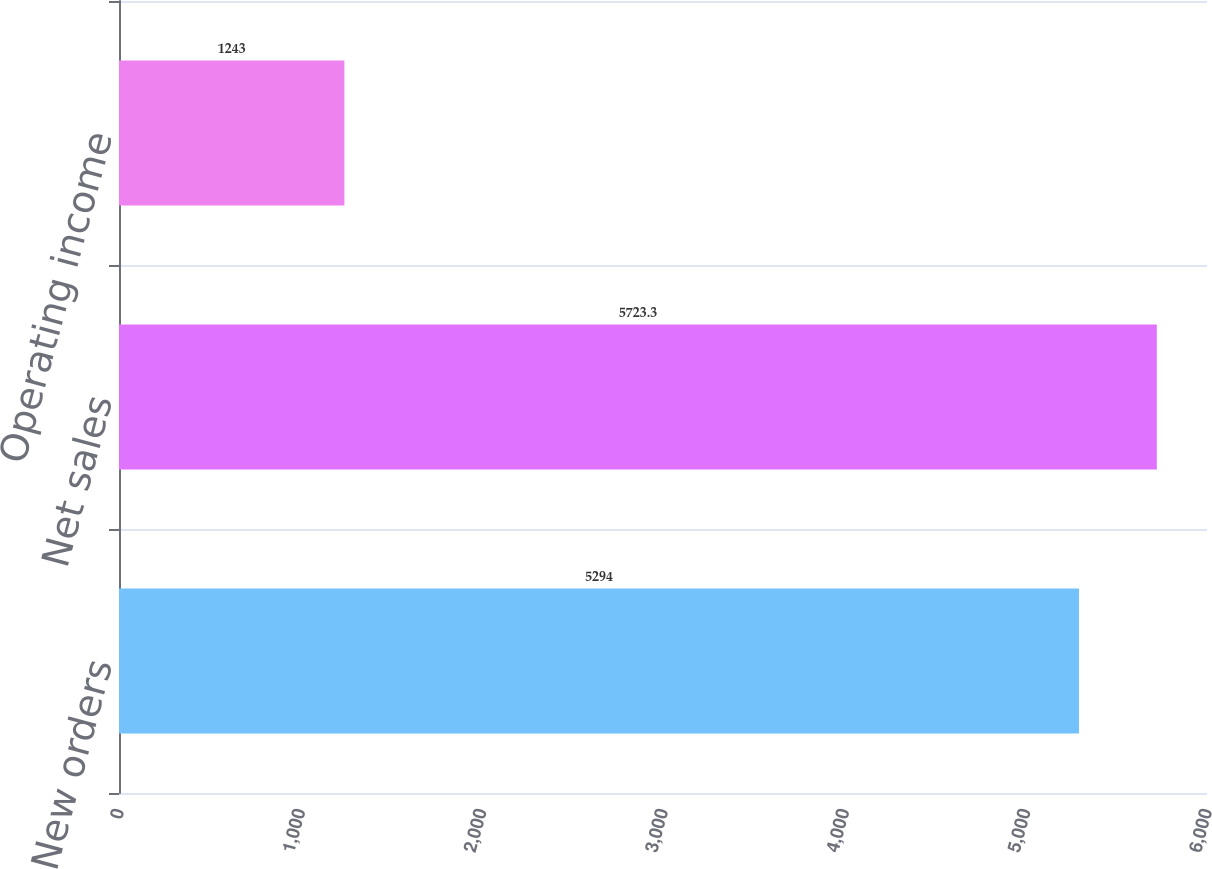<chart> <loc_0><loc_0><loc_500><loc_500><bar_chart><fcel>New orders<fcel>Net sales<fcel>Operating income<nl><fcel>5294<fcel>5723.3<fcel>1243<nl></chart> 